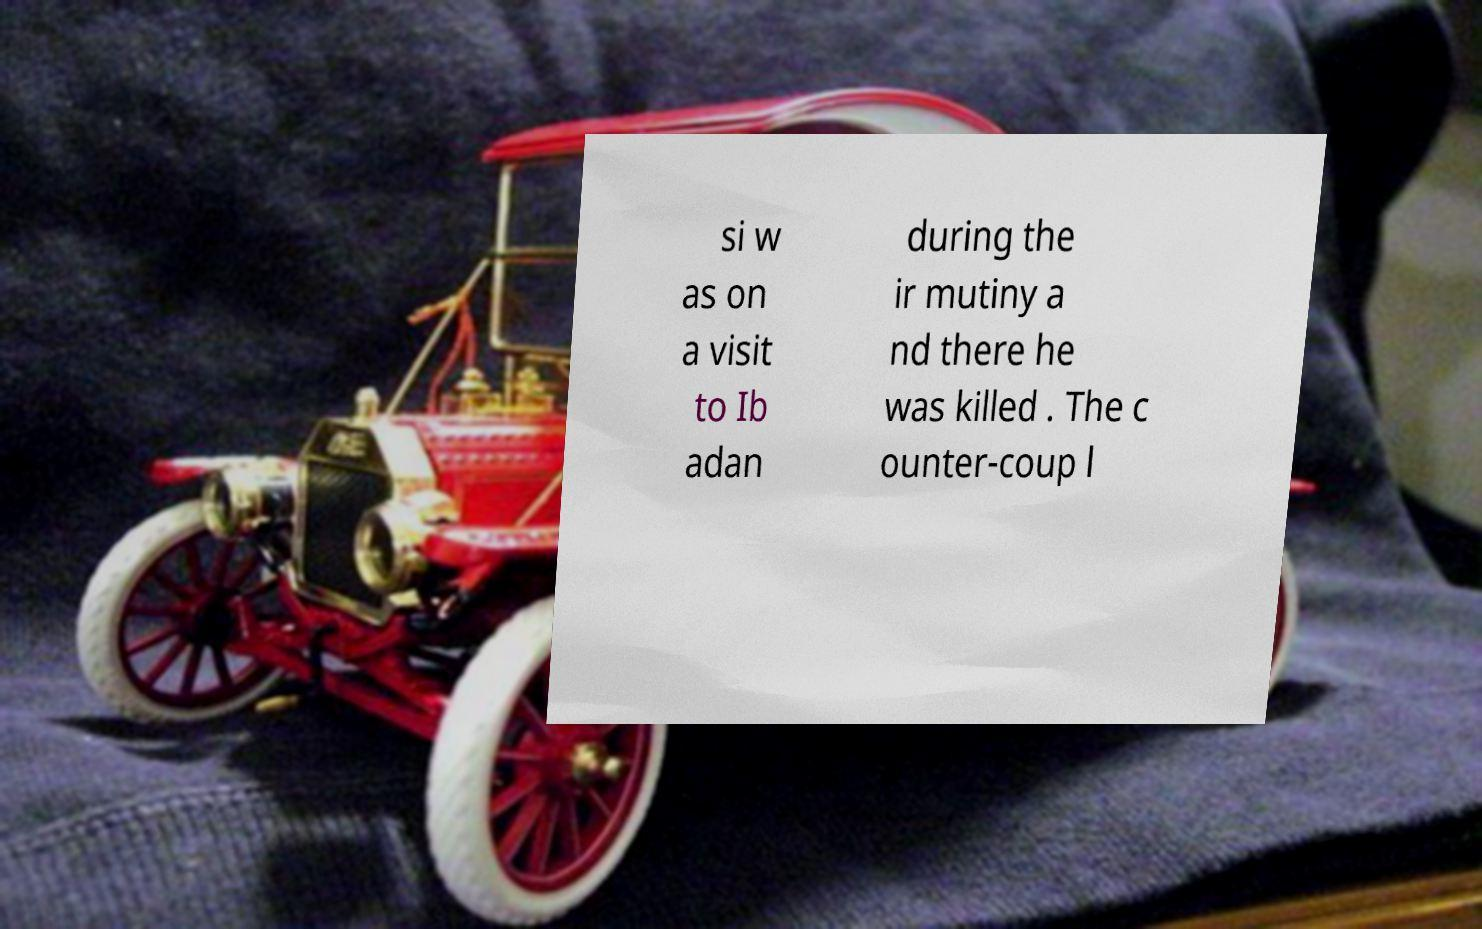For documentation purposes, I need the text within this image transcribed. Could you provide that? si w as on a visit to Ib adan during the ir mutiny a nd there he was killed . The c ounter-coup l 